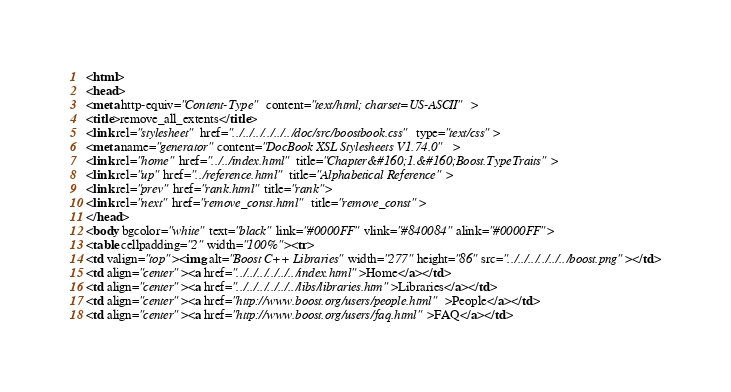Convert code to text. <code><loc_0><loc_0><loc_500><loc_500><_HTML_><html>
<head>
<meta http-equiv="Content-Type" content="text/html; charset=US-ASCII">
<title>remove_all_extents</title>
<link rel="stylesheet" href="../../../../../../doc/src/boostbook.css" type="text/css">
<meta name="generator" content="DocBook XSL Stylesheets V1.74.0">
<link rel="home" href="../../index.html" title="Chapter&#160;1.&#160;Boost.TypeTraits">
<link rel="up" href="../reference.html" title="Alphabetical Reference">
<link rel="prev" href="rank.html" title="rank">
<link rel="next" href="remove_const.html" title="remove_const">
</head>
<body bgcolor="white" text="black" link="#0000FF" vlink="#840084" alink="#0000FF">
<table cellpadding="2" width="100%"><tr>
<td valign="top"><img alt="Boost C++ Libraries" width="277" height="86" src="../../../../../../boost.png"></td>
<td align="center"><a href="../../../../../../index.html">Home</a></td>
<td align="center"><a href="../../../../../../libs/libraries.htm">Libraries</a></td>
<td align="center"><a href="http://www.boost.org/users/people.html">People</a></td>
<td align="center"><a href="http://www.boost.org/users/faq.html">FAQ</a></td></code> 